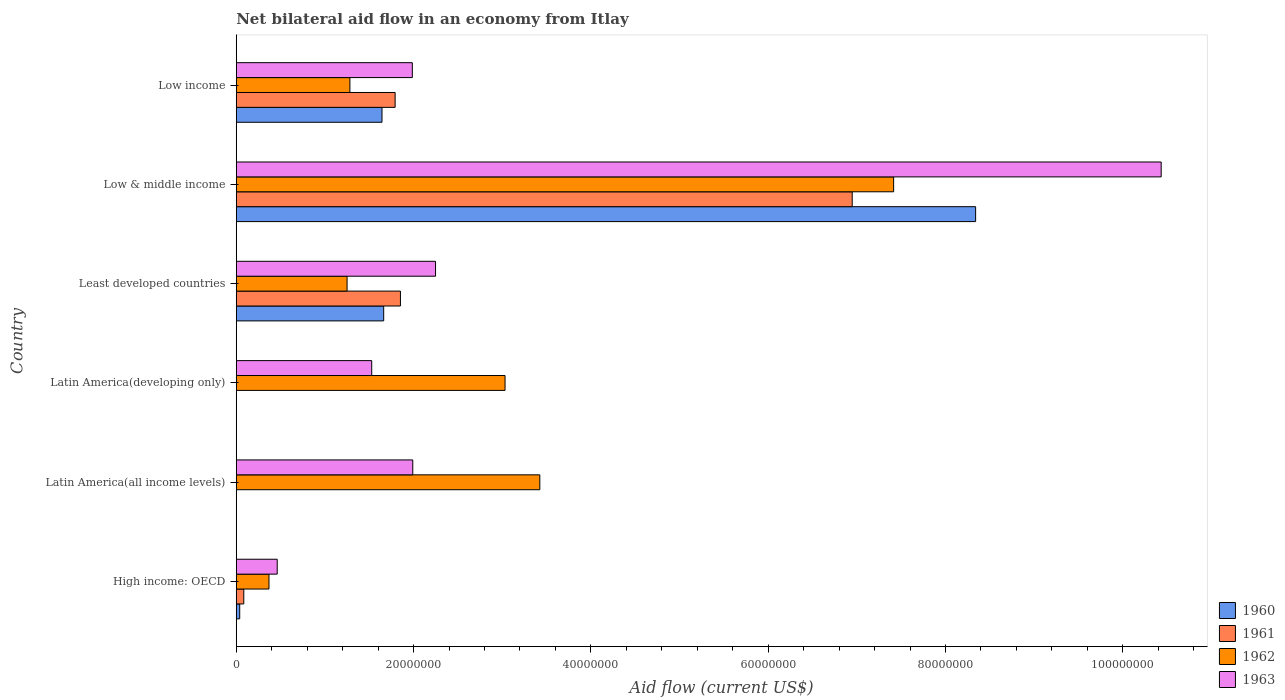How many groups of bars are there?
Your response must be concise. 6. What is the label of the 5th group of bars from the top?
Offer a very short reply. Latin America(all income levels). What is the net bilateral aid flow in 1961 in Latin America(developing only)?
Make the answer very short. 0. Across all countries, what is the maximum net bilateral aid flow in 1960?
Make the answer very short. 8.34e+07. Across all countries, what is the minimum net bilateral aid flow in 1963?
Keep it short and to the point. 4.62e+06. In which country was the net bilateral aid flow in 1961 maximum?
Provide a succinct answer. Low & middle income. What is the total net bilateral aid flow in 1963 in the graph?
Give a very brief answer. 1.86e+08. What is the difference between the net bilateral aid flow in 1961 in High income: OECD and that in Low & middle income?
Provide a succinct answer. -6.86e+07. What is the difference between the net bilateral aid flow in 1960 in Latin America(all income levels) and the net bilateral aid flow in 1962 in Low & middle income?
Your answer should be very brief. -7.42e+07. What is the average net bilateral aid flow in 1963 per country?
Offer a terse response. 3.11e+07. What is the difference between the net bilateral aid flow in 1960 and net bilateral aid flow in 1961 in Low & middle income?
Ensure brevity in your answer.  1.39e+07. In how many countries, is the net bilateral aid flow in 1963 greater than 24000000 US$?
Offer a terse response. 1. What is the ratio of the net bilateral aid flow in 1961 in High income: OECD to that in Least developed countries?
Offer a terse response. 0.05. Is the net bilateral aid flow in 1961 in Least developed countries less than that in Low income?
Your answer should be very brief. No. What is the difference between the highest and the second highest net bilateral aid flow in 1960?
Make the answer very short. 6.68e+07. What is the difference between the highest and the lowest net bilateral aid flow in 1960?
Offer a very short reply. 8.34e+07. In how many countries, is the net bilateral aid flow in 1960 greater than the average net bilateral aid flow in 1960 taken over all countries?
Give a very brief answer. 1. What is the difference between two consecutive major ticks on the X-axis?
Make the answer very short. 2.00e+07. Are the values on the major ticks of X-axis written in scientific E-notation?
Offer a very short reply. No. Does the graph contain any zero values?
Offer a very short reply. Yes. Where does the legend appear in the graph?
Keep it short and to the point. Bottom right. How are the legend labels stacked?
Keep it short and to the point. Vertical. What is the title of the graph?
Offer a terse response. Net bilateral aid flow in an economy from Itlay. What is the label or title of the X-axis?
Make the answer very short. Aid flow (current US$). What is the label or title of the Y-axis?
Offer a terse response. Country. What is the Aid flow (current US$) of 1960 in High income: OECD?
Ensure brevity in your answer.  3.90e+05. What is the Aid flow (current US$) of 1961 in High income: OECD?
Offer a terse response. 8.50e+05. What is the Aid flow (current US$) in 1962 in High income: OECD?
Your answer should be very brief. 3.69e+06. What is the Aid flow (current US$) of 1963 in High income: OECD?
Ensure brevity in your answer.  4.62e+06. What is the Aid flow (current US$) in 1962 in Latin America(all income levels)?
Your answer should be very brief. 3.42e+07. What is the Aid flow (current US$) in 1963 in Latin America(all income levels)?
Ensure brevity in your answer.  1.99e+07. What is the Aid flow (current US$) of 1960 in Latin America(developing only)?
Offer a terse response. 0. What is the Aid flow (current US$) of 1962 in Latin America(developing only)?
Ensure brevity in your answer.  3.03e+07. What is the Aid flow (current US$) of 1963 in Latin America(developing only)?
Give a very brief answer. 1.53e+07. What is the Aid flow (current US$) of 1960 in Least developed countries?
Offer a terse response. 1.66e+07. What is the Aid flow (current US$) of 1961 in Least developed countries?
Give a very brief answer. 1.85e+07. What is the Aid flow (current US$) in 1962 in Least developed countries?
Offer a very short reply. 1.25e+07. What is the Aid flow (current US$) in 1963 in Least developed countries?
Offer a terse response. 2.25e+07. What is the Aid flow (current US$) in 1960 in Low & middle income?
Offer a terse response. 8.34e+07. What is the Aid flow (current US$) in 1961 in Low & middle income?
Provide a short and direct response. 6.95e+07. What is the Aid flow (current US$) of 1962 in Low & middle income?
Offer a terse response. 7.42e+07. What is the Aid flow (current US$) of 1963 in Low & middle income?
Ensure brevity in your answer.  1.04e+08. What is the Aid flow (current US$) of 1960 in Low income?
Provide a succinct answer. 1.64e+07. What is the Aid flow (current US$) in 1961 in Low income?
Your answer should be very brief. 1.79e+07. What is the Aid flow (current US$) of 1962 in Low income?
Your answer should be compact. 1.28e+07. What is the Aid flow (current US$) of 1963 in Low income?
Provide a succinct answer. 1.99e+07. Across all countries, what is the maximum Aid flow (current US$) in 1960?
Make the answer very short. 8.34e+07. Across all countries, what is the maximum Aid flow (current US$) in 1961?
Your response must be concise. 6.95e+07. Across all countries, what is the maximum Aid flow (current US$) of 1962?
Your answer should be compact. 7.42e+07. Across all countries, what is the maximum Aid flow (current US$) in 1963?
Your answer should be very brief. 1.04e+08. Across all countries, what is the minimum Aid flow (current US$) in 1962?
Give a very brief answer. 3.69e+06. Across all countries, what is the minimum Aid flow (current US$) in 1963?
Offer a terse response. 4.62e+06. What is the total Aid flow (current US$) in 1960 in the graph?
Provide a short and direct response. 1.17e+08. What is the total Aid flow (current US$) of 1961 in the graph?
Your answer should be compact. 1.07e+08. What is the total Aid flow (current US$) in 1962 in the graph?
Offer a very short reply. 1.68e+08. What is the total Aid flow (current US$) of 1963 in the graph?
Keep it short and to the point. 1.86e+08. What is the difference between the Aid flow (current US$) in 1962 in High income: OECD and that in Latin America(all income levels)?
Ensure brevity in your answer.  -3.06e+07. What is the difference between the Aid flow (current US$) in 1963 in High income: OECD and that in Latin America(all income levels)?
Make the answer very short. -1.53e+07. What is the difference between the Aid flow (current US$) in 1962 in High income: OECD and that in Latin America(developing only)?
Your answer should be very brief. -2.66e+07. What is the difference between the Aid flow (current US$) of 1963 in High income: OECD and that in Latin America(developing only)?
Give a very brief answer. -1.07e+07. What is the difference between the Aid flow (current US$) in 1960 in High income: OECD and that in Least developed countries?
Your answer should be compact. -1.62e+07. What is the difference between the Aid flow (current US$) in 1961 in High income: OECD and that in Least developed countries?
Keep it short and to the point. -1.77e+07. What is the difference between the Aid flow (current US$) in 1962 in High income: OECD and that in Least developed countries?
Make the answer very short. -8.81e+06. What is the difference between the Aid flow (current US$) of 1963 in High income: OECD and that in Least developed countries?
Provide a short and direct response. -1.79e+07. What is the difference between the Aid flow (current US$) in 1960 in High income: OECD and that in Low & middle income?
Offer a very short reply. -8.30e+07. What is the difference between the Aid flow (current US$) in 1961 in High income: OECD and that in Low & middle income?
Your answer should be very brief. -6.86e+07. What is the difference between the Aid flow (current US$) in 1962 in High income: OECD and that in Low & middle income?
Offer a very short reply. -7.05e+07. What is the difference between the Aid flow (current US$) of 1963 in High income: OECD and that in Low & middle income?
Provide a succinct answer. -9.97e+07. What is the difference between the Aid flow (current US$) in 1960 in High income: OECD and that in Low income?
Your answer should be compact. -1.60e+07. What is the difference between the Aid flow (current US$) of 1961 in High income: OECD and that in Low income?
Your response must be concise. -1.71e+07. What is the difference between the Aid flow (current US$) in 1962 in High income: OECD and that in Low income?
Make the answer very short. -9.13e+06. What is the difference between the Aid flow (current US$) in 1963 in High income: OECD and that in Low income?
Provide a succinct answer. -1.52e+07. What is the difference between the Aid flow (current US$) of 1962 in Latin America(all income levels) and that in Latin America(developing only)?
Keep it short and to the point. 3.92e+06. What is the difference between the Aid flow (current US$) in 1963 in Latin America(all income levels) and that in Latin America(developing only)?
Keep it short and to the point. 4.63e+06. What is the difference between the Aid flow (current US$) of 1962 in Latin America(all income levels) and that in Least developed countries?
Your answer should be compact. 2.17e+07. What is the difference between the Aid flow (current US$) of 1963 in Latin America(all income levels) and that in Least developed countries?
Provide a succinct answer. -2.57e+06. What is the difference between the Aid flow (current US$) of 1962 in Latin America(all income levels) and that in Low & middle income?
Ensure brevity in your answer.  -3.99e+07. What is the difference between the Aid flow (current US$) of 1963 in Latin America(all income levels) and that in Low & middle income?
Your answer should be compact. -8.44e+07. What is the difference between the Aid flow (current US$) in 1962 in Latin America(all income levels) and that in Low income?
Keep it short and to the point. 2.14e+07. What is the difference between the Aid flow (current US$) of 1963 in Latin America(all income levels) and that in Low income?
Provide a short and direct response. 5.00e+04. What is the difference between the Aid flow (current US$) of 1962 in Latin America(developing only) and that in Least developed countries?
Offer a very short reply. 1.78e+07. What is the difference between the Aid flow (current US$) of 1963 in Latin America(developing only) and that in Least developed countries?
Your answer should be very brief. -7.20e+06. What is the difference between the Aid flow (current US$) in 1962 in Latin America(developing only) and that in Low & middle income?
Your answer should be very brief. -4.38e+07. What is the difference between the Aid flow (current US$) of 1963 in Latin America(developing only) and that in Low & middle income?
Provide a short and direct response. -8.90e+07. What is the difference between the Aid flow (current US$) of 1962 in Latin America(developing only) and that in Low income?
Your response must be concise. 1.75e+07. What is the difference between the Aid flow (current US$) in 1963 in Latin America(developing only) and that in Low income?
Keep it short and to the point. -4.58e+06. What is the difference between the Aid flow (current US$) of 1960 in Least developed countries and that in Low & middle income?
Provide a short and direct response. -6.68e+07. What is the difference between the Aid flow (current US$) of 1961 in Least developed countries and that in Low & middle income?
Offer a terse response. -5.10e+07. What is the difference between the Aid flow (current US$) of 1962 in Least developed countries and that in Low & middle income?
Make the answer very short. -6.16e+07. What is the difference between the Aid flow (current US$) of 1963 in Least developed countries and that in Low & middle income?
Offer a very short reply. -8.18e+07. What is the difference between the Aid flow (current US$) of 1960 in Least developed countries and that in Low income?
Provide a succinct answer. 1.90e+05. What is the difference between the Aid flow (current US$) in 1962 in Least developed countries and that in Low income?
Your answer should be compact. -3.20e+05. What is the difference between the Aid flow (current US$) in 1963 in Least developed countries and that in Low income?
Offer a terse response. 2.62e+06. What is the difference between the Aid flow (current US$) of 1960 in Low & middle income and that in Low income?
Your answer should be compact. 6.70e+07. What is the difference between the Aid flow (current US$) in 1961 in Low & middle income and that in Low income?
Give a very brief answer. 5.16e+07. What is the difference between the Aid flow (current US$) in 1962 in Low & middle income and that in Low income?
Ensure brevity in your answer.  6.13e+07. What is the difference between the Aid flow (current US$) in 1963 in Low & middle income and that in Low income?
Ensure brevity in your answer.  8.45e+07. What is the difference between the Aid flow (current US$) in 1960 in High income: OECD and the Aid flow (current US$) in 1962 in Latin America(all income levels)?
Your answer should be very brief. -3.38e+07. What is the difference between the Aid flow (current US$) of 1960 in High income: OECD and the Aid flow (current US$) of 1963 in Latin America(all income levels)?
Ensure brevity in your answer.  -1.95e+07. What is the difference between the Aid flow (current US$) in 1961 in High income: OECD and the Aid flow (current US$) in 1962 in Latin America(all income levels)?
Provide a short and direct response. -3.34e+07. What is the difference between the Aid flow (current US$) of 1961 in High income: OECD and the Aid flow (current US$) of 1963 in Latin America(all income levels)?
Offer a terse response. -1.91e+07. What is the difference between the Aid flow (current US$) in 1962 in High income: OECD and the Aid flow (current US$) in 1963 in Latin America(all income levels)?
Ensure brevity in your answer.  -1.62e+07. What is the difference between the Aid flow (current US$) in 1960 in High income: OECD and the Aid flow (current US$) in 1962 in Latin America(developing only)?
Give a very brief answer. -2.99e+07. What is the difference between the Aid flow (current US$) in 1960 in High income: OECD and the Aid flow (current US$) in 1963 in Latin America(developing only)?
Make the answer very short. -1.49e+07. What is the difference between the Aid flow (current US$) in 1961 in High income: OECD and the Aid flow (current US$) in 1962 in Latin America(developing only)?
Make the answer very short. -2.95e+07. What is the difference between the Aid flow (current US$) of 1961 in High income: OECD and the Aid flow (current US$) of 1963 in Latin America(developing only)?
Give a very brief answer. -1.44e+07. What is the difference between the Aid flow (current US$) in 1962 in High income: OECD and the Aid flow (current US$) in 1963 in Latin America(developing only)?
Your response must be concise. -1.16e+07. What is the difference between the Aid flow (current US$) in 1960 in High income: OECD and the Aid flow (current US$) in 1961 in Least developed countries?
Provide a short and direct response. -1.81e+07. What is the difference between the Aid flow (current US$) in 1960 in High income: OECD and the Aid flow (current US$) in 1962 in Least developed countries?
Provide a succinct answer. -1.21e+07. What is the difference between the Aid flow (current US$) in 1960 in High income: OECD and the Aid flow (current US$) in 1963 in Least developed countries?
Ensure brevity in your answer.  -2.21e+07. What is the difference between the Aid flow (current US$) of 1961 in High income: OECD and the Aid flow (current US$) of 1962 in Least developed countries?
Make the answer very short. -1.16e+07. What is the difference between the Aid flow (current US$) of 1961 in High income: OECD and the Aid flow (current US$) of 1963 in Least developed countries?
Your response must be concise. -2.16e+07. What is the difference between the Aid flow (current US$) in 1962 in High income: OECD and the Aid flow (current US$) in 1963 in Least developed countries?
Give a very brief answer. -1.88e+07. What is the difference between the Aid flow (current US$) in 1960 in High income: OECD and the Aid flow (current US$) in 1961 in Low & middle income?
Your answer should be very brief. -6.91e+07. What is the difference between the Aid flow (current US$) of 1960 in High income: OECD and the Aid flow (current US$) of 1962 in Low & middle income?
Make the answer very short. -7.38e+07. What is the difference between the Aid flow (current US$) in 1960 in High income: OECD and the Aid flow (current US$) in 1963 in Low & middle income?
Ensure brevity in your answer.  -1.04e+08. What is the difference between the Aid flow (current US$) of 1961 in High income: OECD and the Aid flow (current US$) of 1962 in Low & middle income?
Offer a terse response. -7.33e+07. What is the difference between the Aid flow (current US$) in 1961 in High income: OECD and the Aid flow (current US$) in 1963 in Low & middle income?
Give a very brief answer. -1.03e+08. What is the difference between the Aid flow (current US$) in 1962 in High income: OECD and the Aid flow (current US$) in 1963 in Low & middle income?
Give a very brief answer. -1.01e+08. What is the difference between the Aid flow (current US$) of 1960 in High income: OECD and the Aid flow (current US$) of 1961 in Low income?
Provide a succinct answer. -1.75e+07. What is the difference between the Aid flow (current US$) of 1960 in High income: OECD and the Aid flow (current US$) of 1962 in Low income?
Your answer should be compact. -1.24e+07. What is the difference between the Aid flow (current US$) of 1960 in High income: OECD and the Aid flow (current US$) of 1963 in Low income?
Make the answer very short. -1.95e+07. What is the difference between the Aid flow (current US$) in 1961 in High income: OECD and the Aid flow (current US$) in 1962 in Low income?
Offer a terse response. -1.20e+07. What is the difference between the Aid flow (current US$) of 1961 in High income: OECD and the Aid flow (current US$) of 1963 in Low income?
Offer a terse response. -1.90e+07. What is the difference between the Aid flow (current US$) in 1962 in High income: OECD and the Aid flow (current US$) in 1963 in Low income?
Ensure brevity in your answer.  -1.62e+07. What is the difference between the Aid flow (current US$) in 1962 in Latin America(all income levels) and the Aid flow (current US$) in 1963 in Latin America(developing only)?
Make the answer very short. 1.90e+07. What is the difference between the Aid flow (current US$) of 1962 in Latin America(all income levels) and the Aid flow (current US$) of 1963 in Least developed countries?
Offer a terse response. 1.18e+07. What is the difference between the Aid flow (current US$) in 1962 in Latin America(all income levels) and the Aid flow (current US$) in 1963 in Low & middle income?
Ensure brevity in your answer.  -7.01e+07. What is the difference between the Aid flow (current US$) of 1962 in Latin America(all income levels) and the Aid flow (current US$) of 1963 in Low income?
Give a very brief answer. 1.44e+07. What is the difference between the Aid flow (current US$) in 1962 in Latin America(developing only) and the Aid flow (current US$) in 1963 in Least developed countries?
Your response must be concise. 7.84e+06. What is the difference between the Aid flow (current US$) in 1962 in Latin America(developing only) and the Aid flow (current US$) in 1963 in Low & middle income?
Keep it short and to the point. -7.40e+07. What is the difference between the Aid flow (current US$) in 1962 in Latin America(developing only) and the Aid flow (current US$) in 1963 in Low income?
Provide a succinct answer. 1.05e+07. What is the difference between the Aid flow (current US$) in 1960 in Least developed countries and the Aid flow (current US$) in 1961 in Low & middle income?
Make the answer very short. -5.28e+07. What is the difference between the Aid flow (current US$) of 1960 in Least developed countries and the Aid flow (current US$) of 1962 in Low & middle income?
Your answer should be very brief. -5.75e+07. What is the difference between the Aid flow (current US$) in 1960 in Least developed countries and the Aid flow (current US$) in 1963 in Low & middle income?
Keep it short and to the point. -8.77e+07. What is the difference between the Aid flow (current US$) of 1961 in Least developed countries and the Aid flow (current US$) of 1962 in Low & middle income?
Offer a very short reply. -5.56e+07. What is the difference between the Aid flow (current US$) in 1961 in Least developed countries and the Aid flow (current US$) in 1963 in Low & middle income?
Keep it short and to the point. -8.58e+07. What is the difference between the Aid flow (current US$) of 1962 in Least developed countries and the Aid flow (current US$) of 1963 in Low & middle income?
Your answer should be compact. -9.18e+07. What is the difference between the Aid flow (current US$) in 1960 in Least developed countries and the Aid flow (current US$) in 1961 in Low income?
Your answer should be compact. -1.29e+06. What is the difference between the Aid flow (current US$) of 1960 in Least developed countries and the Aid flow (current US$) of 1962 in Low income?
Make the answer very short. 3.81e+06. What is the difference between the Aid flow (current US$) in 1960 in Least developed countries and the Aid flow (current US$) in 1963 in Low income?
Keep it short and to the point. -3.23e+06. What is the difference between the Aid flow (current US$) in 1961 in Least developed countries and the Aid flow (current US$) in 1962 in Low income?
Make the answer very short. 5.70e+06. What is the difference between the Aid flow (current US$) of 1961 in Least developed countries and the Aid flow (current US$) of 1963 in Low income?
Your answer should be compact. -1.34e+06. What is the difference between the Aid flow (current US$) in 1962 in Least developed countries and the Aid flow (current US$) in 1963 in Low income?
Give a very brief answer. -7.36e+06. What is the difference between the Aid flow (current US$) in 1960 in Low & middle income and the Aid flow (current US$) in 1961 in Low income?
Offer a very short reply. 6.55e+07. What is the difference between the Aid flow (current US$) of 1960 in Low & middle income and the Aid flow (current US$) of 1962 in Low income?
Your answer should be compact. 7.06e+07. What is the difference between the Aid flow (current US$) in 1960 in Low & middle income and the Aid flow (current US$) in 1963 in Low income?
Keep it short and to the point. 6.35e+07. What is the difference between the Aid flow (current US$) of 1961 in Low & middle income and the Aid flow (current US$) of 1962 in Low income?
Ensure brevity in your answer.  5.67e+07. What is the difference between the Aid flow (current US$) in 1961 in Low & middle income and the Aid flow (current US$) in 1963 in Low income?
Make the answer very short. 4.96e+07. What is the difference between the Aid flow (current US$) of 1962 in Low & middle income and the Aid flow (current US$) of 1963 in Low income?
Provide a succinct answer. 5.43e+07. What is the average Aid flow (current US$) in 1960 per country?
Your response must be concise. 1.95e+07. What is the average Aid flow (current US$) in 1961 per country?
Offer a terse response. 1.78e+07. What is the average Aid flow (current US$) of 1962 per country?
Keep it short and to the point. 2.80e+07. What is the average Aid flow (current US$) in 1963 per country?
Provide a succinct answer. 3.11e+07. What is the difference between the Aid flow (current US$) in 1960 and Aid flow (current US$) in 1961 in High income: OECD?
Offer a very short reply. -4.60e+05. What is the difference between the Aid flow (current US$) in 1960 and Aid flow (current US$) in 1962 in High income: OECD?
Ensure brevity in your answer.  -3.30e+06. What is the difference between the Aid flow (current US$) in 1960 and Aid flow (current US$) in 1963 in High income: OECD?
Offer a very short reply. -4.23e+06. What is the difference between the Aid flow (current US$) of 1961 and Aid flow (current US$) of 1962 in High income: OECD?
Ensure brevity in your answer.  -2.84e+06. What is the difference between the Aid flow (current US$) in 1961 and Aid flow (current US$) in 1963 in High income: OECD?
Your response must be concise. -3.77e+06. What is the difference between the Aid flow (current US$) in 1962 and Aid flow (current US$) in 1963 in High income: OECD?
Give a very brief answer. -9.30e+05. What is the difference between the Aid flow (current US$) in 1962 and Aid flow (current US$) in 1963 in Latin America(all income levels)?
Provide a short and direct response. 1.43e+07. What is the difference between the Aid flow (current US$) of 1962 and Aid flow (current US$) of 1963 in Latin America(developing only)?
Provide a short and direct response. 1.50e+07. What is the difference between the Aid flow (current US$) in 1960 and Aid flow (current US$) in 1961 in Least developed countries?
Your answer should be compact. -1.89e+06. What is the difference between the Aid flow (current US$) in 1960 and Aid flow (current US$) in 1962 in Least developed countries?
Provide a succinct answer. 4.13e+06. What is the difference between the Aid flow (current US$) in 1960 and Aid flow (current US$) in 1963 in Least developed countries?
Offer a terse response. -5.85e+06. What is the difference between the Aid flow (current US$) of 1961 and Aid flow (current US$) of 1962 in Least developed countries?
Offer a very short reply. 6.02e+06. What is the difference between the Aid flow (current US$) of 1961 and Aid flow (current US$) of 1963 in Least developed countries?
Make the answer very short. -3.96e+06. What is the difference between the Aid flow (current US$) of 1962 and Aid flow (current US$) of 1963 in Least developed countries?
Make the answer very short. -9.98e+06. What is the difference between the Aid flow (current US$) in 1960 and Aid flow (current US$) in 1961 in Low & middle income?
Keep it short and to the point. 1.39e+07. What is the difference between the Aid flow (current US$) in 1960 and Aid flow (current US$) in 1962 in Low & middle income?
Your answer should be very brief. 9.25e+06. What is the difference between the Aid flow (current US$) in 1960 and Aid flow (current US$) in 1963 in Low & middle income?
Offer a terse response. -2.09e+07. What is the difference between the Aid flow (current US$) in 1961 and Aid flow (current US$) in 1962 in Low & middle income?
Offer a terse response. -4.67e+06. What is the difference between the Aid flow (current US$) in 1961 and Aid flow (current US$) in 1963 in Low & middle income?
Provide a succinct answer. -3.48e+07. What is the difference between the Aid flow (current US$) of 1962 and Aid flow (current US$) of 1963 in Low & middle income?
Keep it short and to the point. -3.02e+07. What is the difference between the Aid flow (current US$) of 1960 and Aid flow (current US$) of 1961 in Low income?
Give a very brief answer. -1.48e+06. What is the difference between the Aid flow (current US$) of 1960 and Aid flow (current US$) of 1962 in Low income?
Your answer should be very brief. 3.62e+06. What is the difference between the Aid flow (current US$) of 1960 and Aid flow (current US$) of 1963 in Low income?
Offer a very short reply. -3.42e+06. What is the difference between the Aid flow (current US$) in 1961 and Aid flow (current US$) in 1962 in Low income?
Make the answer very short. 5.10e+06. What is the difference between the Aid flow (current US$) of 1961 and Aid flow (current US$) of 1963 in Low income?
Keep it short and to the point. -1.94e+06. What is the difference between the Aid flow (current US$) in 1962 and Aid flow (current US$) in 1963 in Low income?
Offer a terse response. -7.04e+06. What is the ratio of the Aid flow (current US$) in 1962 in High income: OECD to that in Latin America(all income levels)?
Make the answer very short. 0.11. What is the ratio of the Aid flow (current US$) in 1963 in High income: OECD to that in Latin America(all income levels)?
Provide a short and direct response. 0.23. What is the ratio of the Aid flow (current US$) in 1962 in High income: OECD to that in Latin America(developing only)?
Offer a very short reply. 0.12. What is the ratio of the Aid flow (current US$) in 1963 in High income: OECD to that in Latin America(developing only)?
Keep it short and to the point. 0.3. What is the ratio of the Aid flow (current US$) in 1960 in High income: OECD to that in Least developed countries?
Offer a very short reply. 0.02. What is the ratio of the Aid flow (current US$) of 1961 in High income: OECD to that in Least developed countries?
Give a very brief answer. 0.05. What is the ratio of the Aid flow (current US$) in 1962 in High income: OECD to that in Least developed countries?
Ensure brevity in your answer.  0.3. What is the ratio of the Aid flow (current US$) of 1963 in High income: OECD to that in Least developed countries?
Your response must be concise. 0.21. What is the ratio of the Aid flow (current US$) of 1960 in High income: OECD to that in Low & middle income?
Provide a succinct answer. 0. What is the ratio of the Aid flow (current US$) in 1961 in High income: OECD to that in Low & middle income?
Provide a short and direct response. 0.01. What is the ratio of the Aid flow (current US$) of 1962 in High income: OECD to that in Low & middle income?
Your answer should be compact. 0.05. What is the ratio of the Aid flow (current US$) in 1963 in High income: OECD to that in Low & middle income?
Make the answer very short. 0.04. What is the ratio of the Aid flow (current US$) of 1960 in High income: OECD to that in Low income?
Provide a succinct answer. 0.02. What is the ratio of the Aid flow (current US$) of 1961 in High income: OECD to that in Low income?
Your response must be concise. 0.05. What is the ratio of the Aid flow (current US$) in 1962 in High income: OECD to that in Low income?
Make the answer very short. 0.29. What is the ratio of the Aid flow (current US$) of 1963 in High income: OECD to that in Low income?
Provide a succinct answer. 0.23. What is the ratio of the Aid flow (current US$) of 1962 in Latin America(all income levels) to that in Latin America(developing only)?
Ensure brevity in your answer.  1.13. What is the ratio of the Aid flow (current US$) in 1963 in Latin America(all income levels) to that in Latin America(developing only)?
Keep it short and to the point. 1.3. What is the ratio of the Aid flow (current US$) of 1962 in Latin America(all income levels) to that in Least developed countries?
Your answer should be very brief. 2.74. What is the ratio of the Aid flow (current US$) in 1963 in Latin America(all income levels) to that in Least developed countries?
Give a very brief answer. 0.89. What is the ratio of the Aid flow (current US$) in 1962 in Latin America(all income levels) to that in Low & middle income?
Provide a succinct answer. 0.46. What is the ratio of the Aid flow (current US$) of 1963 in Latin America(all income levels) to that in Low & middle income?
Provide a succinct answer. 0.19. What is the ratio of the Aid flow (current US$) in 1962 in Latin America(all income levels) to that in Low income?
Your response must be concise. 2.67. What is the ratio of the Aid flow (current US$) of 1962 in Latin America(developing only) to that in Least developed countries?
Provide a short and direct response. 2.43. What is the ratio of the Aid flow (current US$) of 1963 in Latin America(developing only) to that in Least developed countries?
Your response must be concise. 0.68. What is the ratio of the Aid flow (current US$) in 1962 in Latin America(developing only) to that in Low & middle income?
Make the answer very short. 0.41. What is the ratio of the Aid flow (current US$) in 1963 in Latin America(developing only) to that in Low & middle income?
Give a very brief answer. 0.15. What is the ratio of the Aid flow (current US$) of 1962 in Latin America(developing only) to that in Low income?
Keep it short and to the point. 2.37. What is the ratio of the Aid flow (current US$) of 1963 in Latin America(developing only) to that in Low income?
Give a very brief answer. 0.77. What is the ratio of the Aid flow (current US$) of 1960 in Least developed countries to that in Low & middle income?
Ensure brevity in your answer.  0.2. What is the ratio of the Aid flow (current US$) of 1961 in Least developed countries to that in Low & middle income?
Ensure brevity in your answer.  0.27. What is the ratio of the Aid flow (current US$) of 1962 in Least developed countries to that in Low & middle income?
Offer a terse response. 0.17. What is the ratio of the Aid flow (current US$) of 1963 in Least developed countries to that in Low & middle income?
Provide a short and direct response. 0.22. What is the ratio of the Aid flow (current US$) of 1960 in Least developed countries to that in Low income?
Offer a terse response. 1.01. What is the ratio of the Aid flow (current US$) of 1961 in Least developed countries to that in Low income?
Your response must be concise. 1.03. What is the ratio of the Aid flow (current US$) in 1962 in Least developed countries to that in Low income?
Give a very brief answer. 0.97. What is the ratio of the Aid flow (current US$) in 1963 in Least developed countries to that in Low income?
Your answer should be very brief. 1.13. What is the ratio of the Aid flow (current US$) of 1960 in Low & middle income to that in Low income?
Provide a short and direct response. 5.07. What is the ratio of the Aid flow (current US$) of 1961 in Low & middle income to that in Low income?
Offer a terse response. 3.88. What is the ratio of the Aid flow (current US$) of 1962 in Low & middle income to that in Low income?
Your answer should be very brief. 5.78. What is the ratio of the Aid flow (current US$) of 1963 in Low & middle income to that in Low income?
Your answer should be compact. 5.25. What is the difference between the highest and the second highest Aid flow (current US$) in 1960?
Give a very brief answer. 6.68e+07. What is the difference between the highest and the second highest Aid flow (current US$) in 1961?
Offer a terse response. 5.10e+07. What is the difference between the highest and the second highest Aid flow (current US$) in 1962?
Provide a short and direct response. 3.99e+07. What is the difference between the highest and the second highest Aid flow (current US$) of 1963?
Your answer should be very brief. 8.18e+07. What is the difference between the highest and the lowest Aid flow (current US$) of 1960?
Provide a succinct answer. 8.34e+07. What is the difference between the highest and the lowest Aid flow (current US$) in 1961?
Give a very brief answer. 6.95e+07. What is the difference between the highest and the lowest Aid flow (current US$) in 1962?
Offer a terse response. 7.05e+07. What is the difference between the highest and the lowest Aid flow (current US$) in 1963?
Your answer should be very brief. 9.97e+07. 